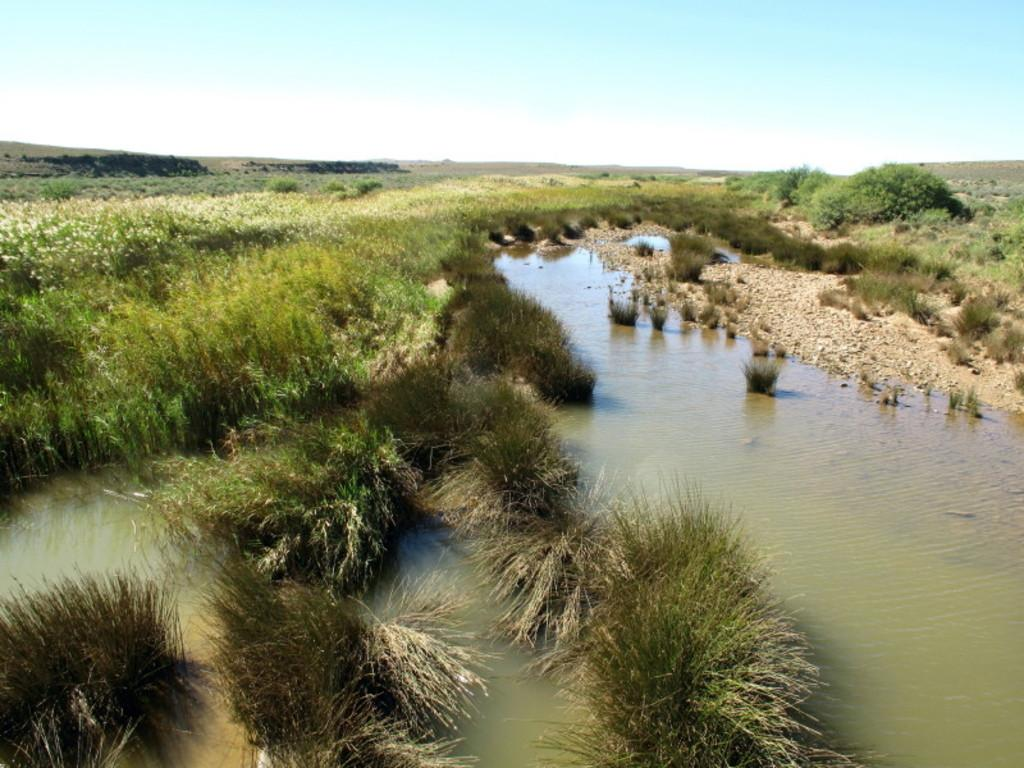What type of body of water is present in the image? There is a lake in the image. What natural element can be seen near the lake? There is a tree in the image. What else is visible in the image besides the lake and tree? The sky is visible in the image. Where is the zoo located in the image? There is no zoo present in the image. What type of wave can be seen in the image? There are no waves present in the image, as it features a lake and not an ocean or sea. 